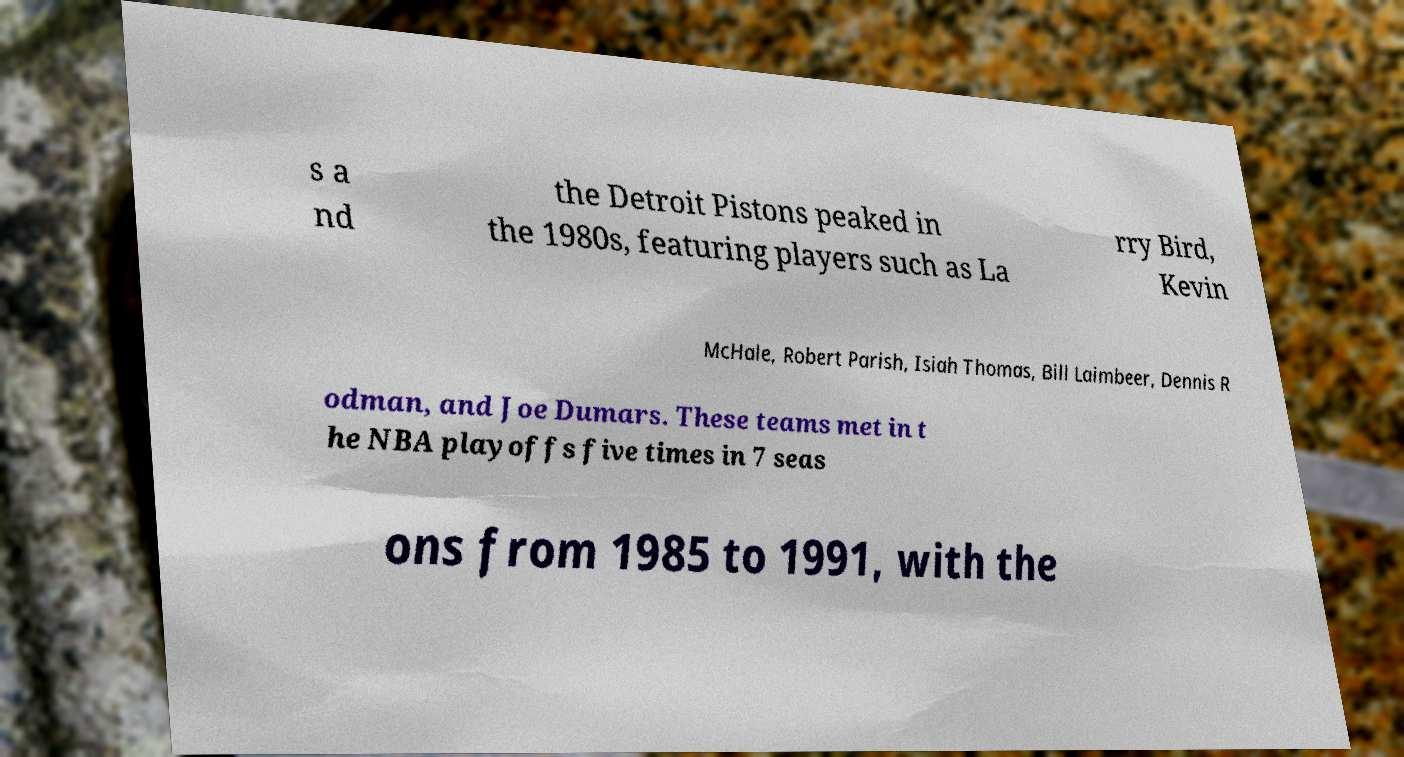Please identify and transcribe the text found in this image. s a nd the Detroit Pistons peaked in the 1980s, featuring players such as La rry Bird, Kevin McHale, Robert Parish, Isiah Thomas, Bill Laimbeer, Dennis R odman, and Joe Dumars. These teams met in t he NBA playoffs five times in 7 seas ons from 1985 to 1991, with the 